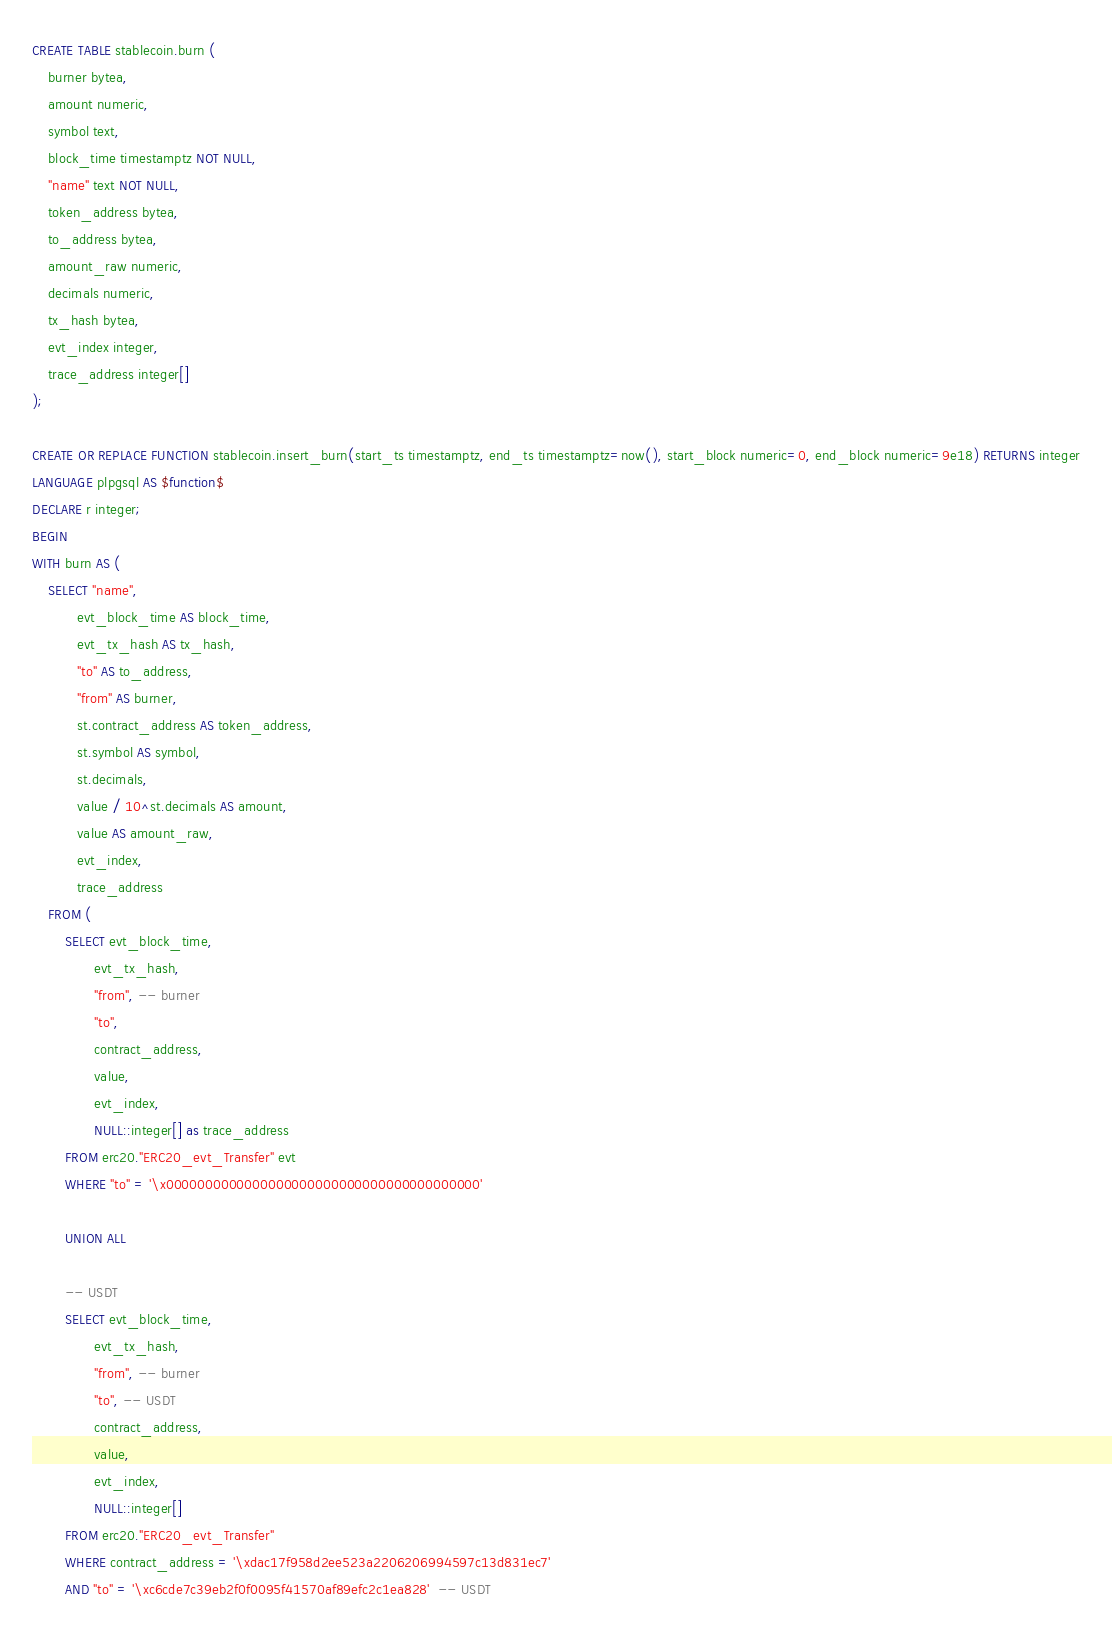Convert code to text. <code><loc_0><loc_0><loc_500><loc_500><_SQL_>CREATE TABLE stablecoin.burn (
    burner bytea,
    amount numeric,
    symbol text,
    block_time timestamptz NOT NULL,
    "name" text NOT NULL,
    token_address bytea,
    to_address bytea,
    amount_raw numeric,
    decimals numeric,
    tx_hash bytea,
    evt_index integer,
    trace_address integer[]
);

CREATE OR REPLACE FUNCTION stablecoin.insert_burn(start_ts timestamptz, end_ts timestamptz=now(), start_block numeric=0, end_block numeric=9e18) RETURNS integer
LANGUAGE plpgsql AS $function$
DECLARE r integer;
BEGIN
WITH burn AS (
    SELECT "name",
           evt_block_time AS block_time,
           evt_tx_hash AS tx_hash,
           "to" AS to_address,
           "from" AS burner,
           st.contract_address AS token_address,
           st.symbol AS symbol,
           st.decimals,
           value / 10^st.decimals AS amount,
           value AS amount_raw,
           evt_index,
           trace_address
    FROM (
        SELECT evt_block_time,
               evt_tx_hash,
               "from", -- burner
               "to",
               contract_address,
               value,
               evt_index,
               NULL::integer[] as trace_address
        FROM erc20."ERC20_evt_Transfer" evt
        WHERE "to" = '\x0000000000000000000000000000000000000000'
       
        UNION ALL
  
        -- USDT
        SELECT evt_block_time,
               evt_tx_hash,
               "from", -- burner
               "to", -- USDT
               contract_address,
               value,
               evt_index,
               NULL::integer[]
        FROM erc20."ERC20_evt_Transfer" 
        WHERE contract_address = '\xdac17f958d2ee523a2206206994597c13d831ec7' 
        AND "to" = '\xc6cde7c39eb2f0f0095f41570af89efc2c1ea828'  -- USDT
</code> 